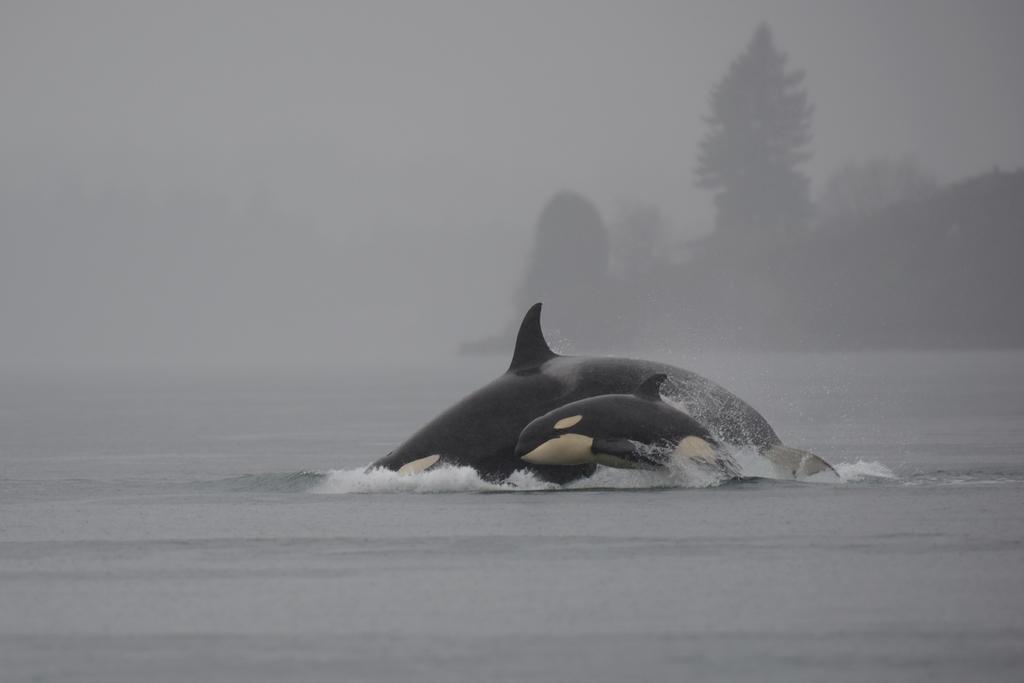How would you summarize this image in a sentence or two? In this image we can see two whales in the water. The background of the image is filled with fog where we can see trees. 